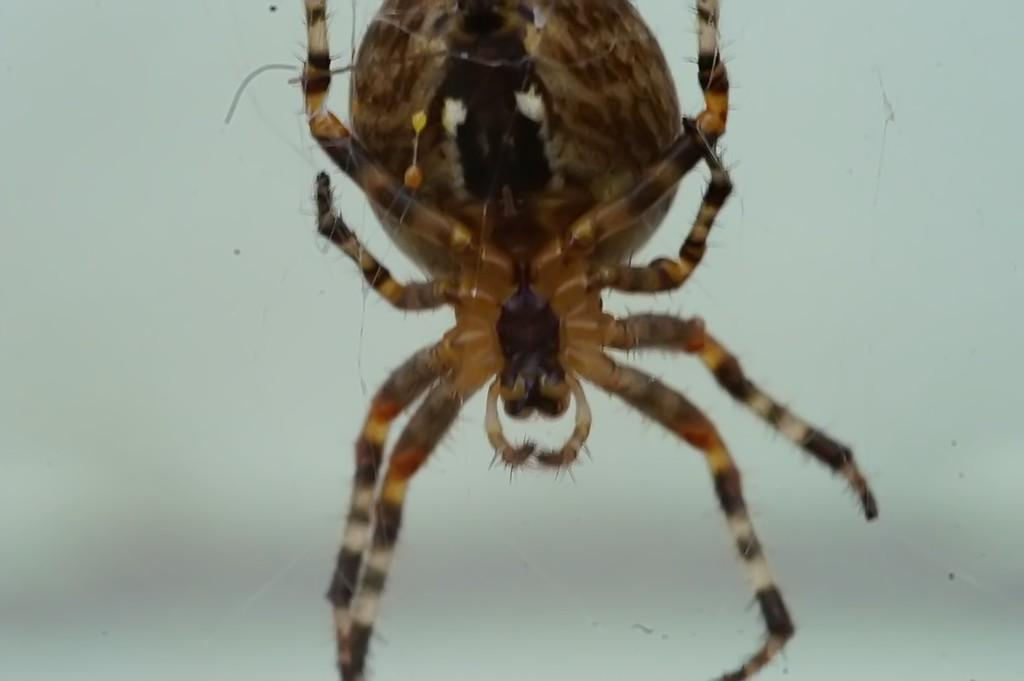What is the main subject of the image? There is a big spider in the image. Can you see a rabbit and a club in the image? No, there is no rabbit or club present in the image; it only features a big spider. 